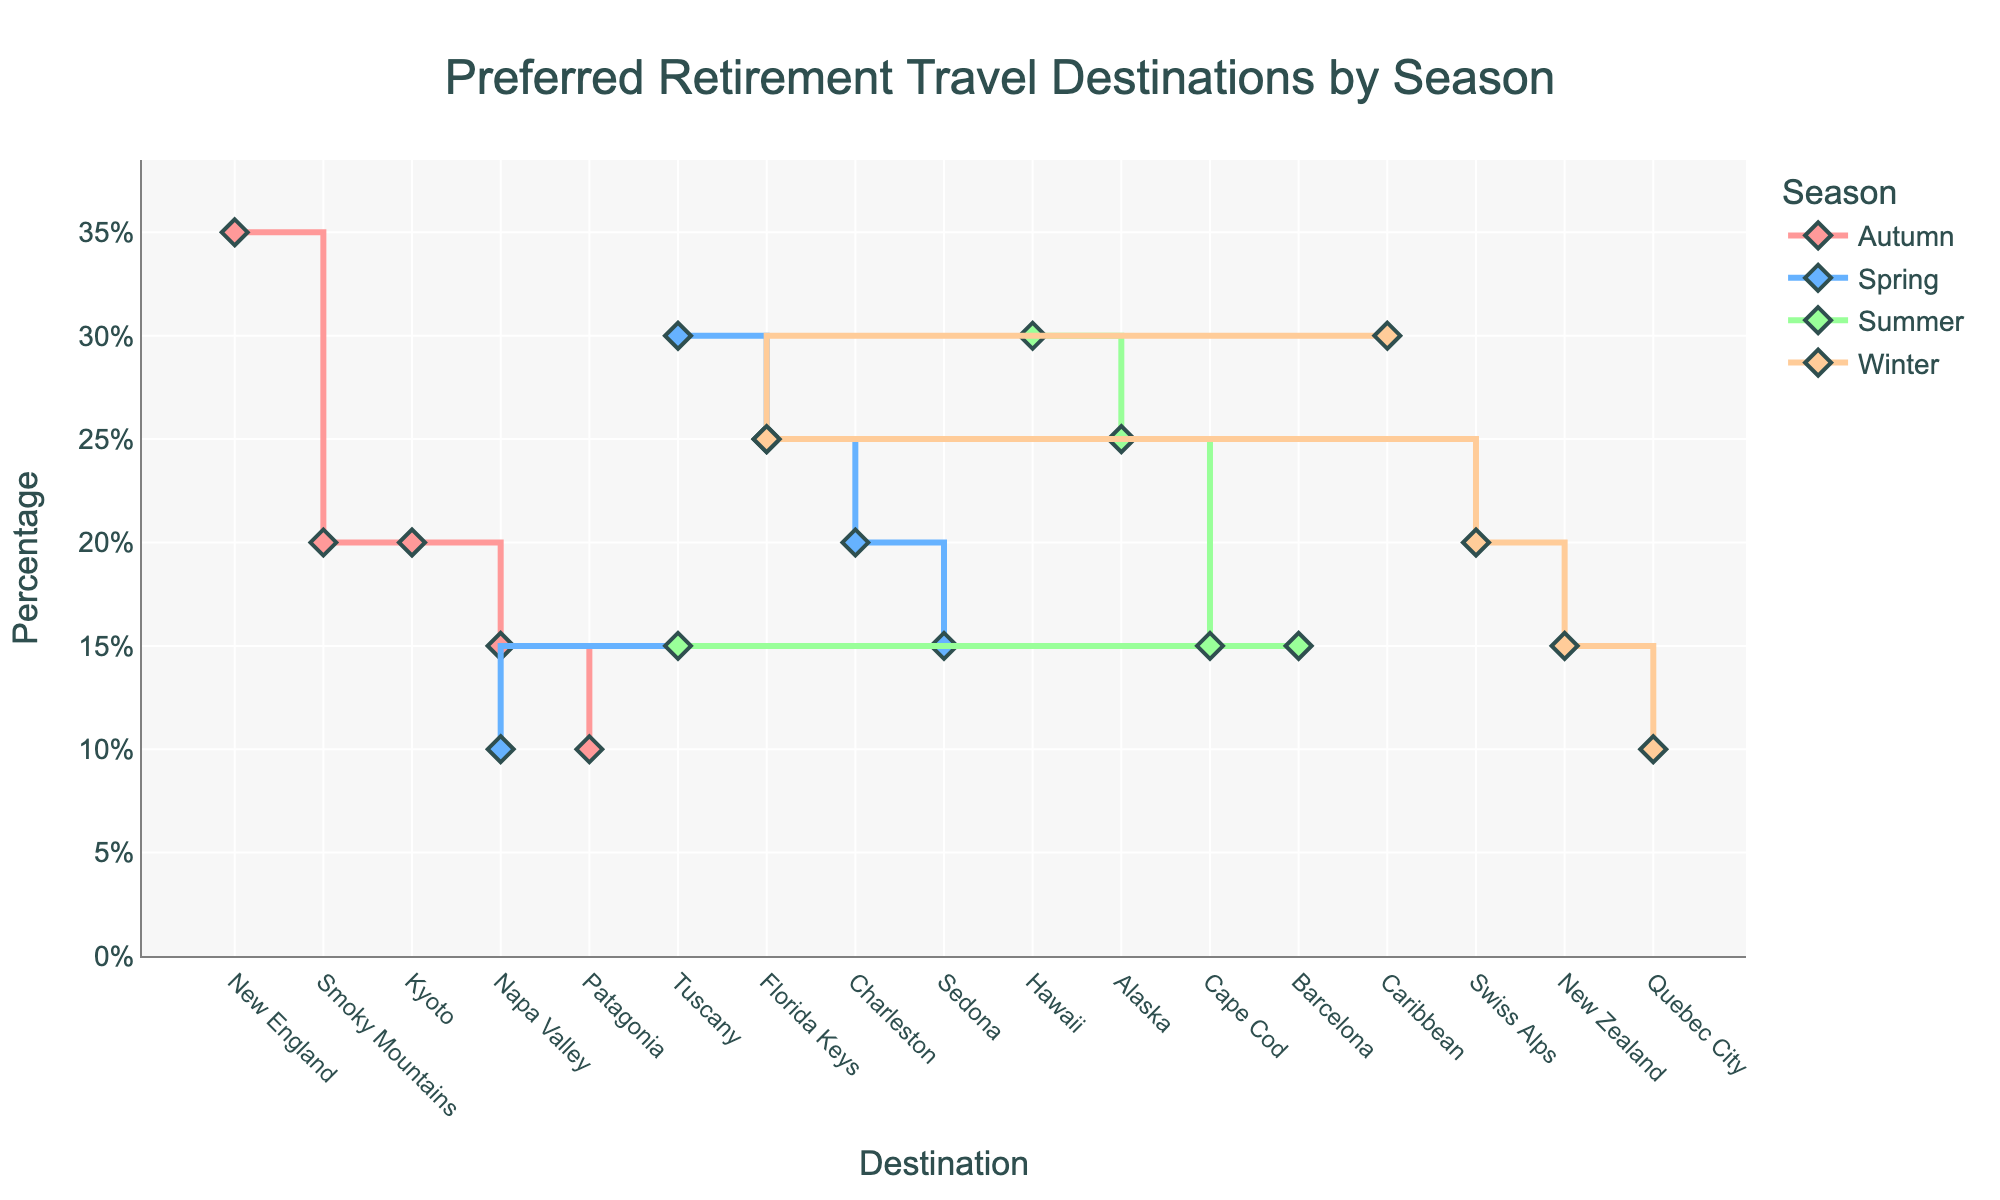what's the title of the figure? The title is shown at the top of the figure, it states the main purpose or topic of the visual representation.
Answer: "Preferred Retirement Travel Destinations by Season" how many destinations are shown for each season? The figure groups data by seasons, and you can count the number of destinations listed for each. For Spring and Winter, there are 5 destinations each, for Summer there are 5 destinations, and for Autumn there are 5 destinations.
Answer: 5 which season has the highest percentage for a single destination? By looking at the y-axis percentages and comparing the highest point for each season, the highest single percentage is in Autumn with New England at 35%.
Answer: Autumn what's the percentage difference between the most preferred and least preferred destinations in Winter? For Winter, the highest is Caribbean at 30% and the lowest is Quebec City at 10%. The difference is 30% - 10% = 20%.
Answer: 20% how many destinations share the same percentage in Summer? Looking at Summer destinations, Cape Cod, Barcelona, and Tuscany each have 15% preference.
Answer: 3 which seasons include Tuscany and what's its percentage each time? Tuscany appears in both Spring and Summer. Spring has it at 30% and Summer at 15%.
Answer: Spring at 30% and Summer at 15% how does the preference for Florida Keys change between Spring and Winter? In Spring, Florida Keys is preferred at 25%. In Winter, it holds the same preference at 25%.
Answer: No change which destination has the highest preference in Autumn and how does it compare to the highest in another season? In Autumn, New England has 35%. Comparing this to the highest in Summer, Hawaii at 30%, New England is 5% higher.
Answer: New England is 5% higher than Hawaii how many seasons show destinations with exactly 20% preference? By observing each season, Charleston in Spring, Alaska in Summer, Smoky Mountains and Kyoto in Autumn, and Swiss Alps in Winter each have 20%.
Answer: 4 seasons what season exhibits the widest range of preferences and what is that range? Comparing the widest range, in Autumn, the highest preference is New England at 35% and the lowest is Patagonia at 10%, which makes a range of 35% - 10% = 25%.
Answer: Autumn with a range of 25% 